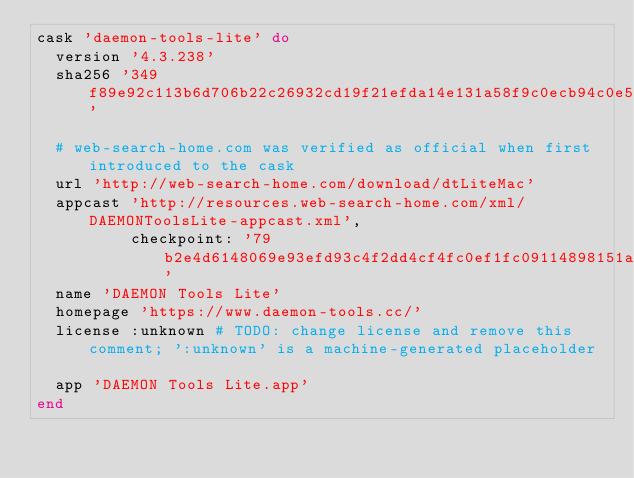Convert code to text. <code><loc_0><loc_0><loc_500><loc_500><_Ruby_>cask 'daemon-tools-lite' do
  version '4.3.238'
  sha256 '349f89e92c113b6d706b22c26932cd19f21efda14e131a58f9c0ecb94c0e5c14'

  # web-search-home.com was verified as official when first introduced to the cask
  url 'http://web-search-home.com/download/dtLiteMac'
  appcast 'http://resources.web-search-home.com/xml/DAEMONToolsLite-appcast.xml',
          checkpoint: '79b2e4d6148069e93efd93c4f2dd4cf4fc0ef1fc09114898151aae03127ad1ad'
  name 'DAEMON Tools Lite'
  homepage 'https://www.daemon-tools.cc/'
  license :unknown # TODO: change license and remove this comment; ':unknown' is a machine-generated placeholder

  app 'DAEMON Tools Lite.app'
end
</code> 